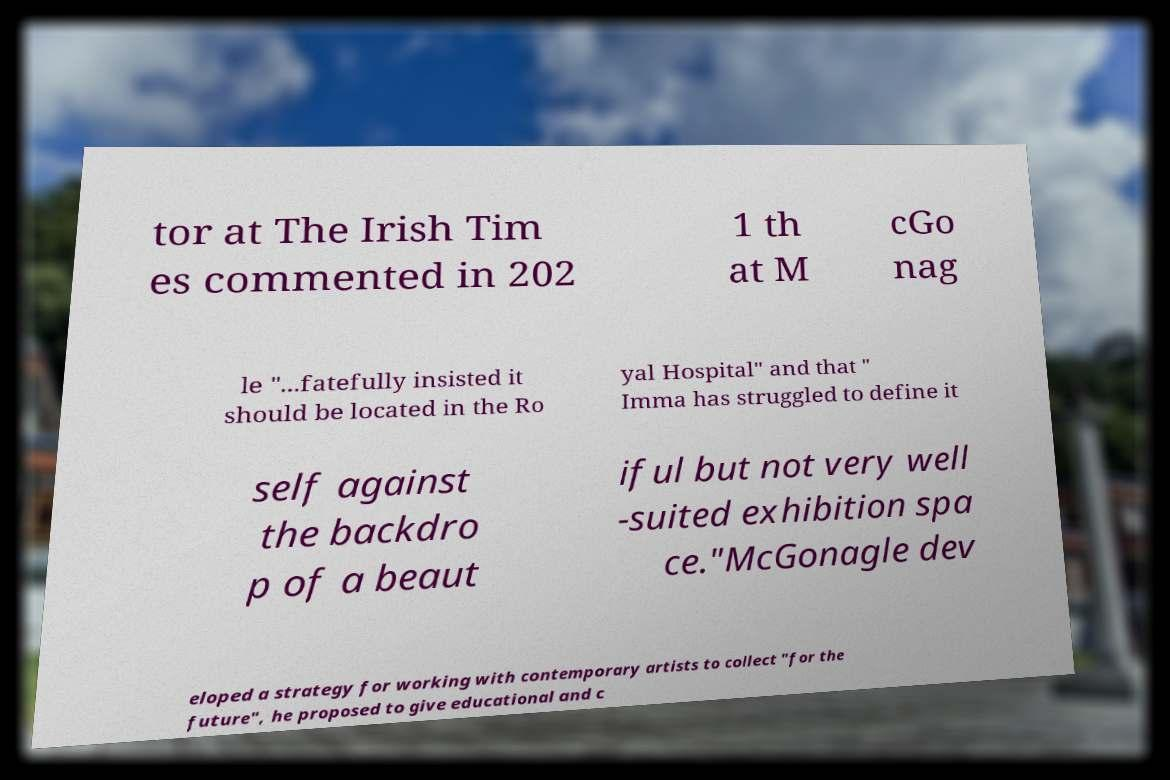For documentation purposes, I need the text within this image transcribed. Could you provide that? tor at The Irish Tim es commented in 202 1 th at M cGo nag le "...fatefully insisted it should be located in the Ro yal Hospital" and that " Imma has struggled to define it self against the backdro p of a beaut iful but not very well -suited exhibition spa ce."McGonagle dev eloped a strategy for working with contemporary artists to collect "for the future", he proposed to give educational and c 